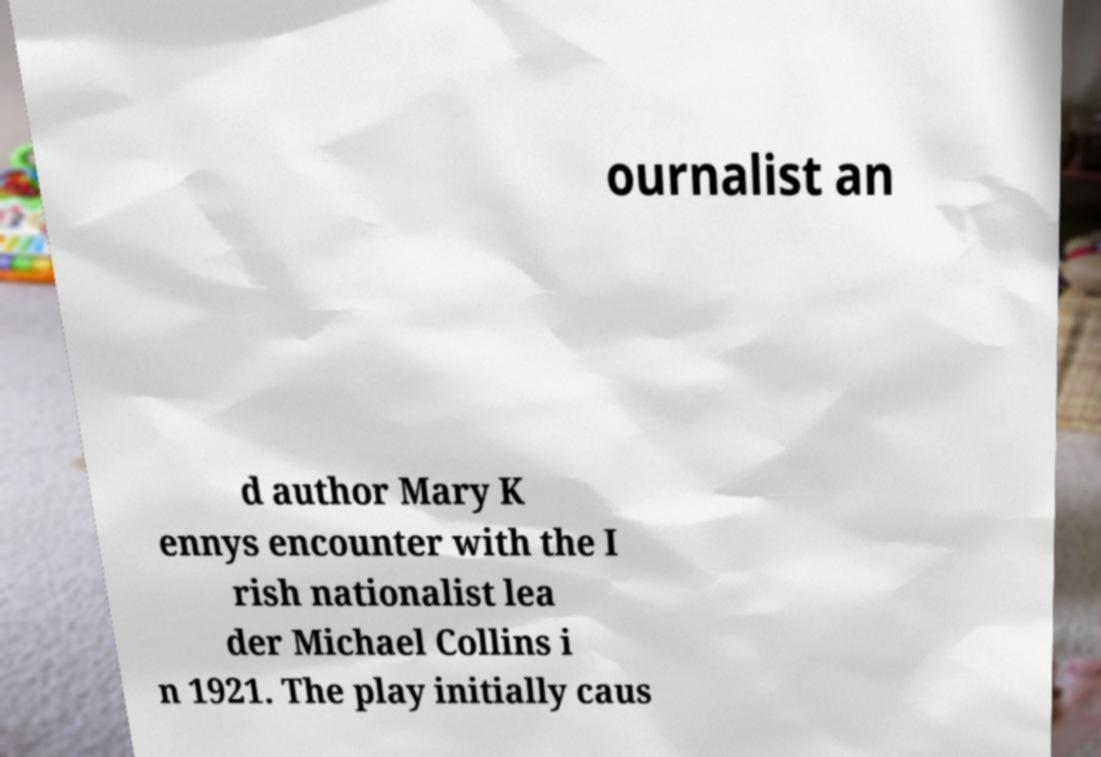There's text embedded in this image that I need extracted. Can you transcribe it verbatim? ournalist an d author Mary K ennys encounter with the I rish nationalist lea der Michael Collins i n 1921. The play initially caus 